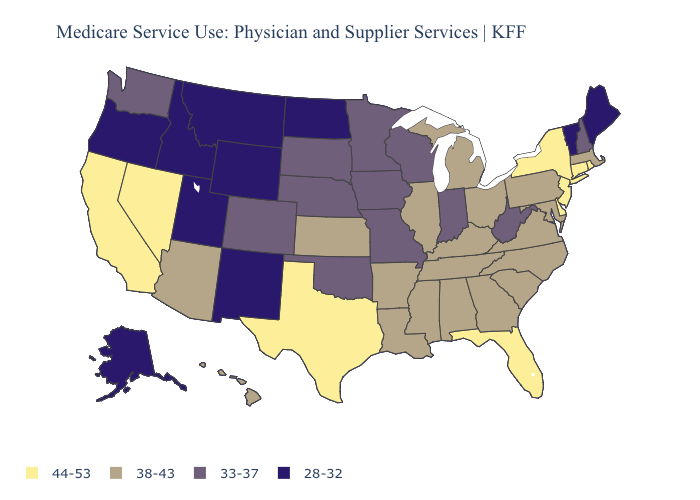Name the states that have a value in the range 38-43?
Keep it brief. Alabama, Arizona, Arkansas, Georgia, Hawaii, Illinois, Kansas, Kentucky, Louisiana, Maryland, Massachusetts, Michigan, Mississippi, North Carolina, Ohio, Pennsylvania, South Carolina, Tennessee, Virginia. Does the map have missing data?
Keep it brief. No. What is the lowest value in the MidWest?
Write a very short answer. 28-32. Among the states that border New Jersey , does Pennsylvania have the lowest value?
Answer briefly. Yes. What is the value of Wyoming?
Concise answer only. 28-32. Which states have the highest value in the USA?
Answer briefly. California, Connecticut, Delaware, Florida, Nevada, New Jersey, New York, Rhode Island, Texas. Does North Dakota have the lowest value in the MidWest?
Keep it brief. Yes. What is the highest value in the USA?
Be succinct. 44-53. What is the value of Alaska?
Quick response, please. 28-32. Which states have the lowest value in the South?
Write a very short answer. Oklahoma, West Virginia. What is the lowest value in the West?
Answer briefly. 28-32. What is the highest value in the USA?
Write a very short answer. 44-53. What is the value of Kansas?
Concise answer only. 38-43. Name the states that have a value in the range 38-43?
Short answer required. Alabama, Arizona, Arkansas, Georgia, Hawaii, Illinois, Kansas, Kentucky, Louisiana, Maryland, Massachusetts, Michigan, Mississippi, North Carolina, Ohio, Pennsylvania, South Carolina, Tennessee, Virginia. What is the highest value in states that border South Dakota?
Write a very short answer. 33-37. 